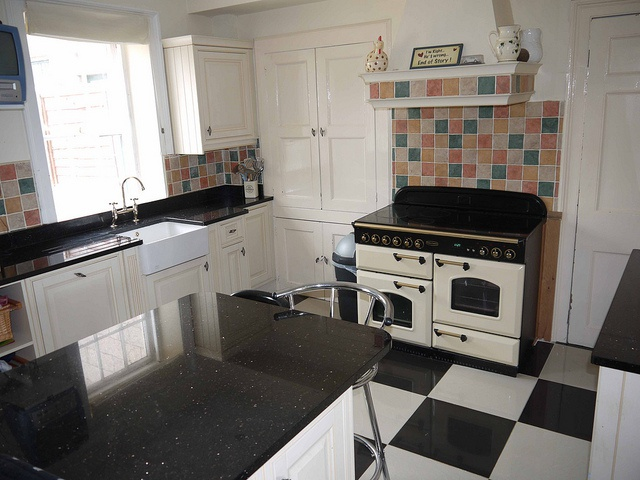Describe the objects in this image and their specific colors. I can see dining table in gray and black tones, oven in gray, black, and darkgray tones, sink in gray, darkgray, lightgray, and black tones, tv in gray, black, darkblue, and navy tones, and chair in gray, darkgray, black, and lightgray tones in this image. 